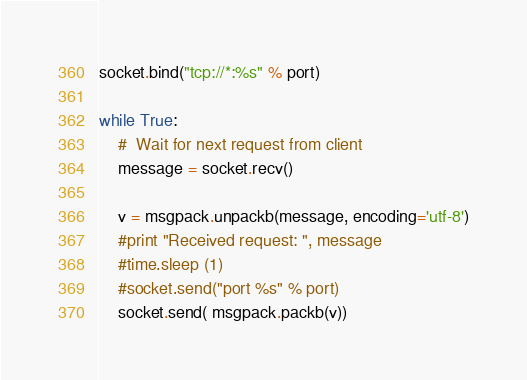Convert code to text. <code><loc_0><loc_0><loc_500><loc_500><_Python_>socket.bind("tcp://*:%s" % port)

while True:
    #  Wait for next request from client
    message = socket.recv()
    
    v = msgpack.unpackb(message, encoding='utf-8')
    #print "Received request: ", message
    #time.sleep (1)  
    #socket.send("port %s" % port)
    socket.send( msgpack.packb(v))</code> 